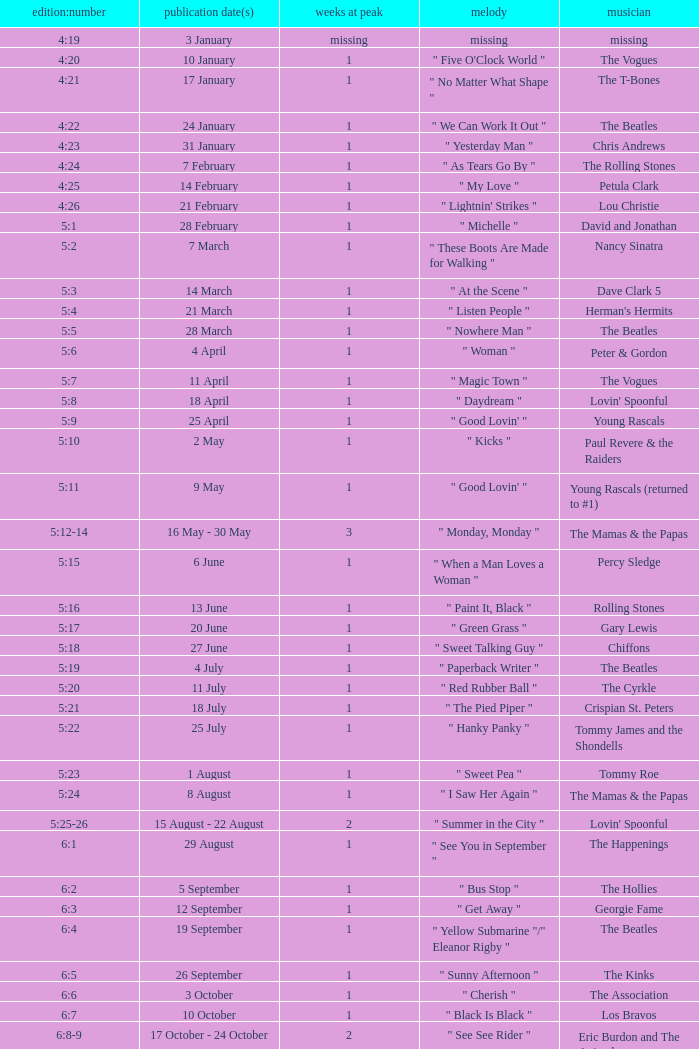With an issue date(s) of 12 September, what is in the column for Weeks on Top? 1.0. 